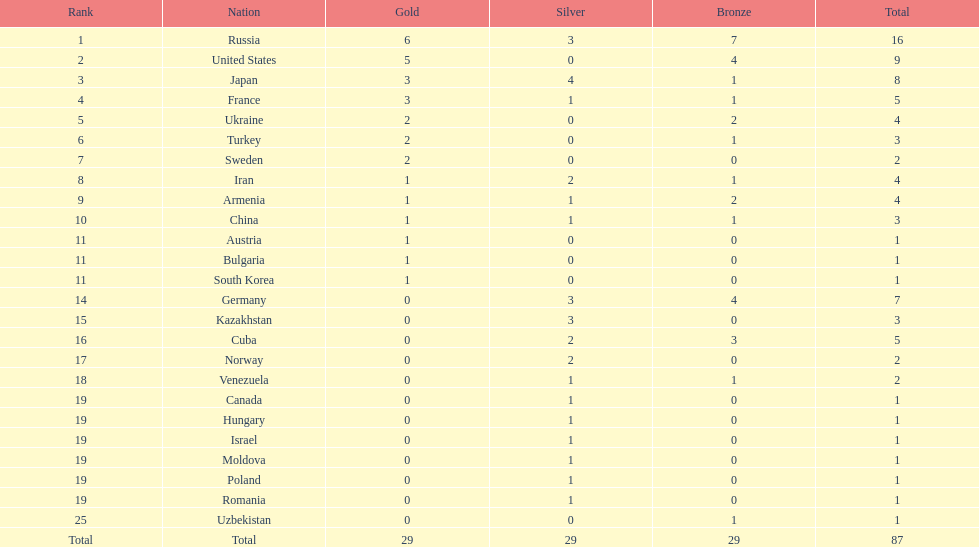Who was ranked just behind turkey? Sweden. 